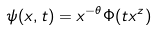Convert formula to latex. <formula><loc_0><loc_0><loc_500><loc_500>\psi ( x , t ) = x ^ { - \theta } \Phi ( t x ^ { z } )</formula> 